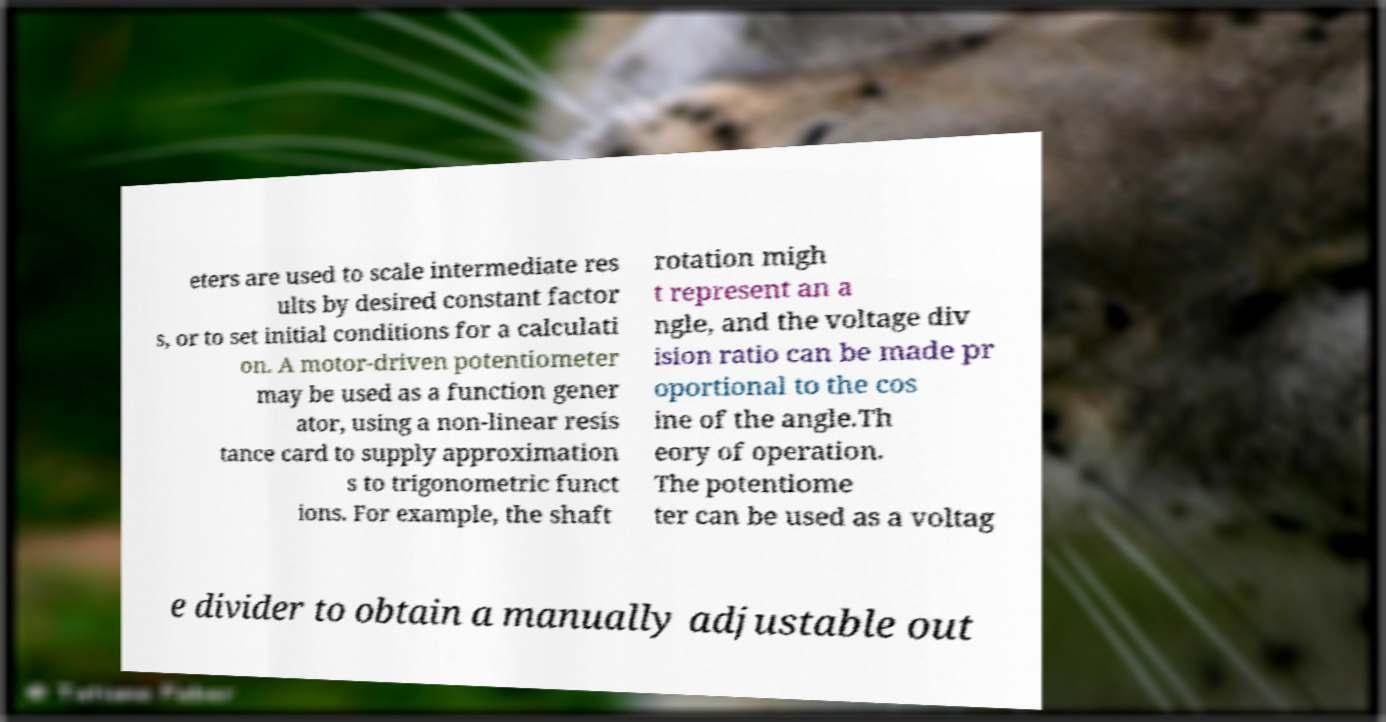Could you extract and type out the text from this image? eters are used to scale intermediate res ults by desired constant factor s, or to set initial conditions for a calculati on. A motor-driven potentiometer may be used as a function gener ator, using a non-linear resis tance card to supply approximation s to trigonometric funct ions. For example, the shaft rotation migh t represent an a ngle, and the voltage div ision ratio can be made pr oportional to the cos ine of the angle.Th eory of operation. The potentiome ter can be used as a voltag e divider to obtain a manually adjustable out 